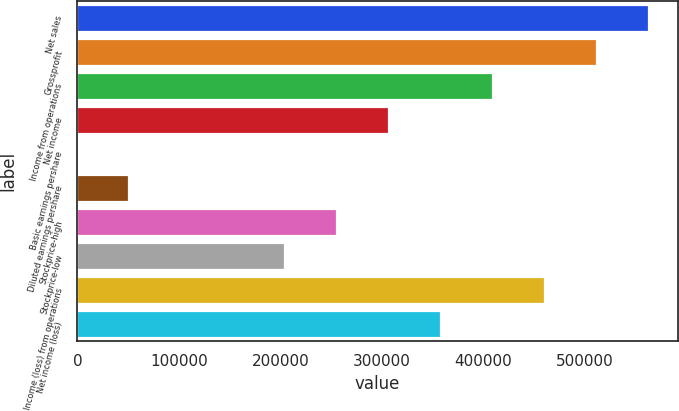<chart> <loc_0><loc_0><loc_500><loc_500><bar_chart><fcel>Net sales<fcel>Grossprofit<fcel>Income from operations<fcel>Net income<fcel>Basic earnings pershare<fcel>Diluted earnings pershare<fcel>Stockprice-high<fcel>Stockprice-low<fcel>Income (loss) from operations<fcel>Net income (loss)<nl><fcel>563406<fcel>512187<fcel>409750<fcel>307312<fcel>0.1<fcel>51218.8<fcel>256094<fcel>204875<fcel>460968<fcel>358531<nl></chart> 